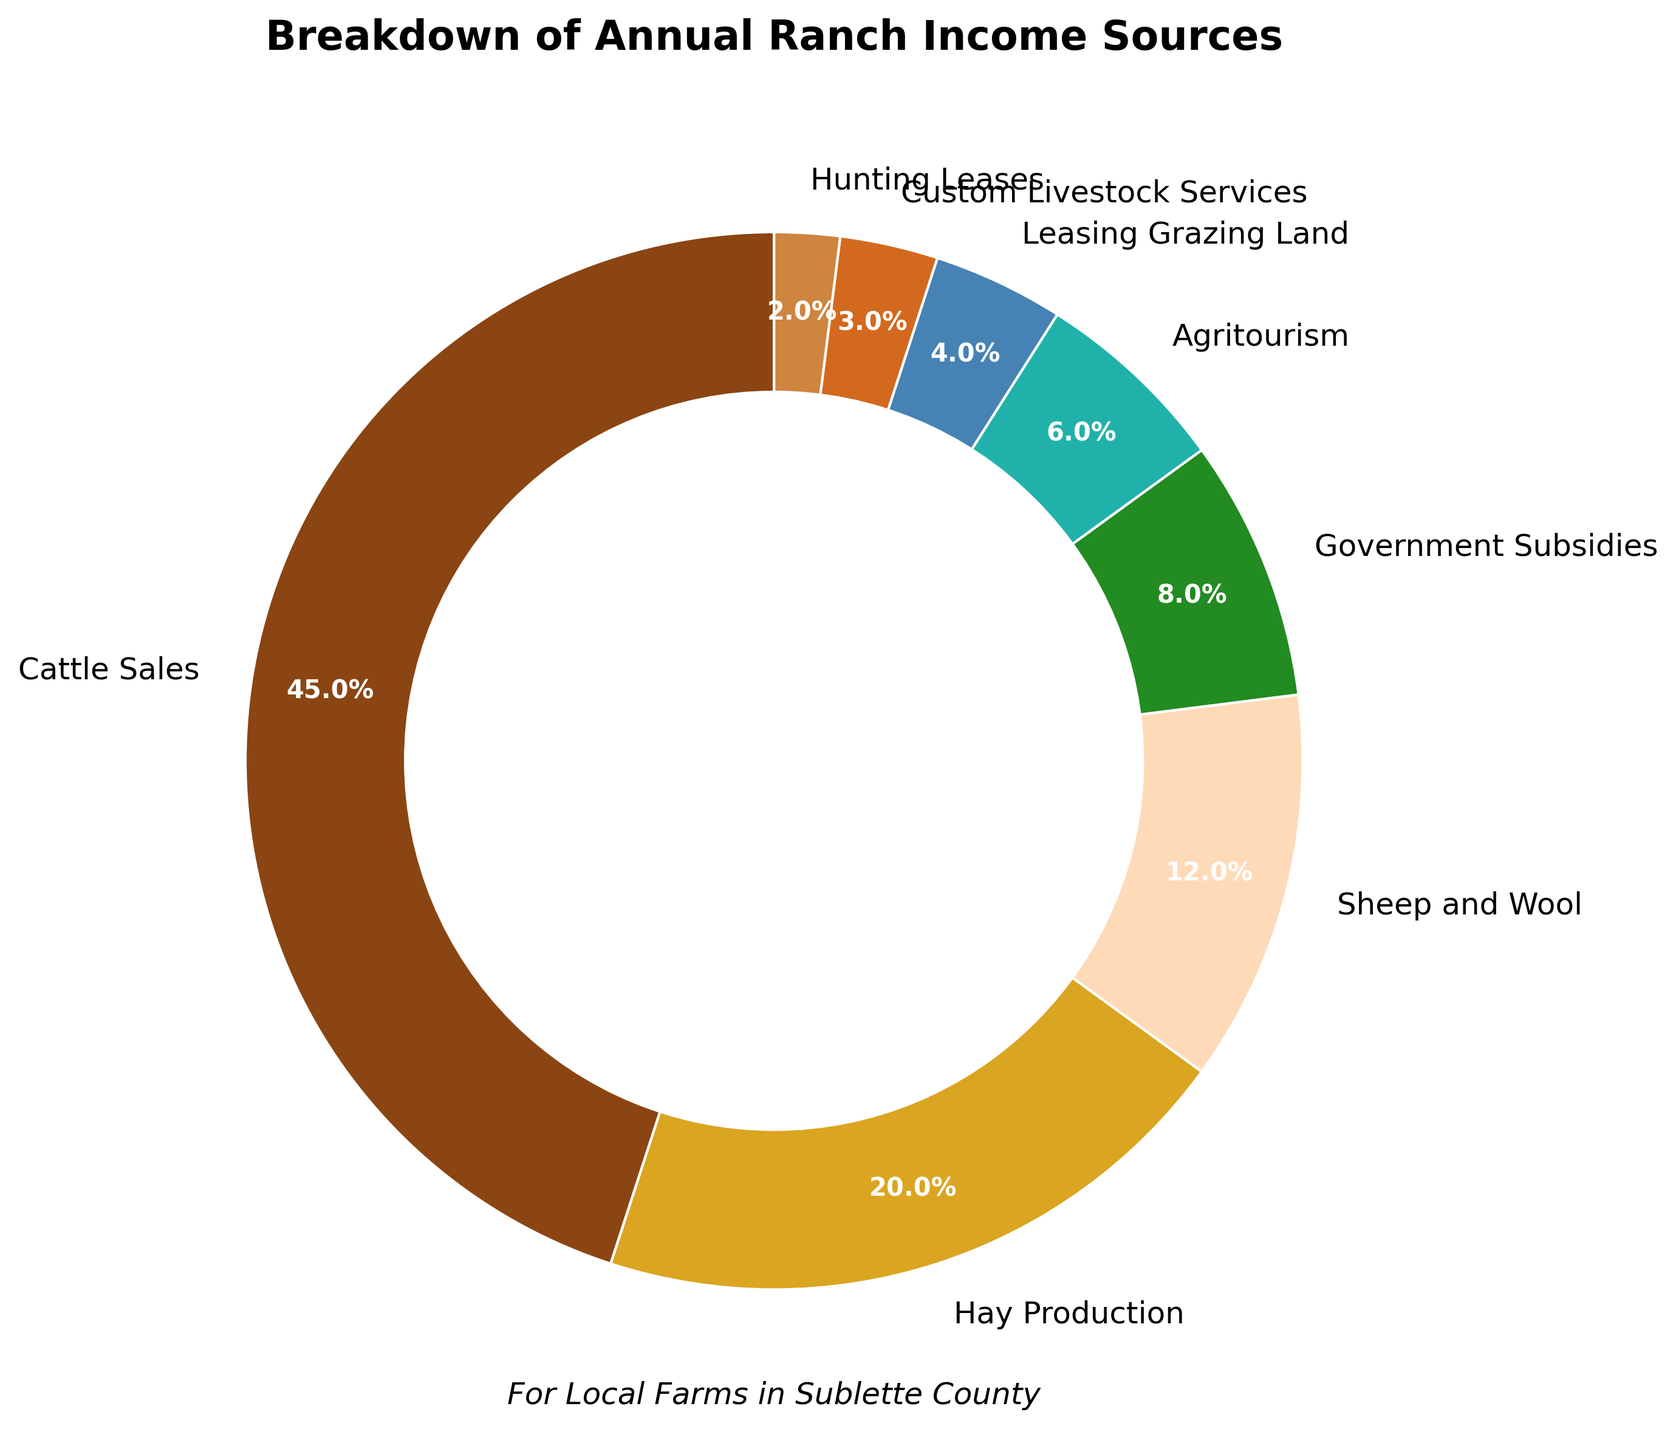What percentage of income is generated from Cattle Sales? The chart directly shows that Cattle Sales account for 45% of the annual ranch income, which is labeled on the pie slice representing Cattle Sales.
Answer: 45% Which income source contributes more, Hay Production or Sheep and Wool? By comparing the percentages shown on the chart, Hay Production is 20% and Sheep and Wool is 12%. Since 20% is greater than 12%, Hay Production contributes more.
Answer: Hay Production What is the combined percentage of income from Government Subsidies and Agritourism? The chart shows that Government Subsidies account for 8% and Agritourism accounts for 6% of the income. Adding these together: 8% + 6% = 14%.
Answer: 14% What are the two smallest income sources mentioned in the chart? By looking at the chart, the smallest slices represent Hunting Leases at 2% and Custom Livestock Services at 3%.
Answer: Hunting Leases and Custom Livestock Services Which income source is less than half the income from Cattle Sales but more than a quarter? Half of Cattle Sales (which are 45%) is 22.5%. The income source between 22.5% and 11.25% is Hay Production at 20%.
Answer: Hay Production Which color represents Agritourism on the chart? The chart shows Agritourism as a section identified by a particular color. Agritourism is represented by a turquoise-like color section.
Answer: Turquoise What is the difference in income percentage between Leasing Grazing Land and Custom Livestock Services? From the chart, Leasing Grazing Land is 4% and Custom Livestock Services is 3%. Subtracting these two: 4% - 3% = 1%.
Answer: 1% What's the percentage of income generated from sources other than Cattle Sales? The total percentage for all sources other than Cattle Sales is the remaining percent of 100% after subtracting Cattle Sales. 100% - 45% = 55%.
Answer: 55% How much more does Hay Production generate compared to Hunting Leases percentage-wise? The chart shows Hay Production at 20% and Hunting Leases at 2%. Subtracting these two: 20% - 2% = 18%.
Answer: 18% Out of all the income sources, which are above 10% and how much do they contribute in total? The sources above 10% are Cattle Sales (45%), Hay Production (20%), and Sheep and Wool (12%). Adding these together: 45% + 20% + 12% = 77%.
Answer: 77% 